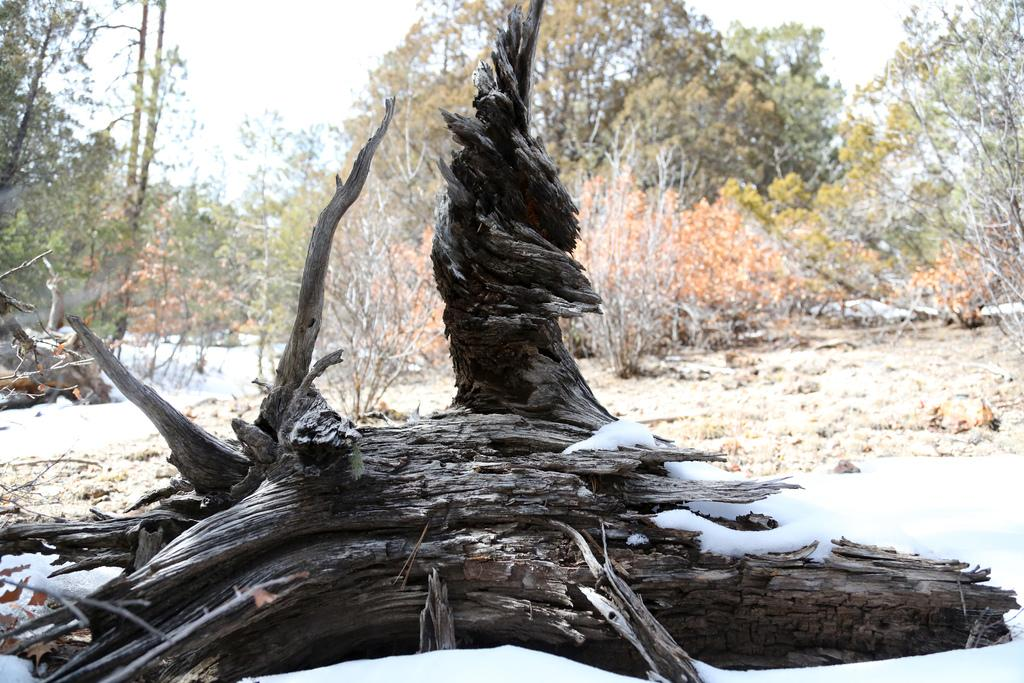What is the main subject in the center of the image? There is a tree trunk in the center of the image. What type of weather is depicted in the image? There is snow at the bottom of the image, indicating a winter scene. What can be seen in the background of the image? There are trees in the background of the image. Can you see a cub swimming in the snow in the image? There is no cub or swimming activity present in the image; it features a tree trunk and snow. 